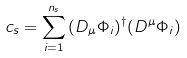<formula> <loc_0><loc_0><loc_500><loc_500>\L c _ { s } = \sum _ { i = 1 } ^ { n _ { s } } \, ( D _ { \mu } \Phi _ { i } ) ^ { \dag } ( D ^ { \mu } \Phi _ { i } )</formula> 